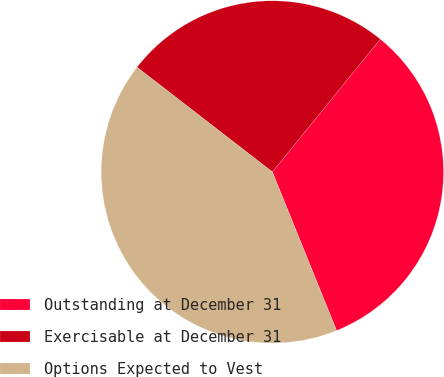Convert chart to OTSL. <chart><loc_0><loc_0><loc_500><loc_500><pie_chart><fcel>Outstanding at December 31<fcel>Exercisable at December 31<fcel>Options Expected to Vest<nl><fcel>33.02%<fcel>25.38%<fcel>41.6%<nl></chart> 